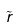Convert formula to latex. <formula><loc_0><loc_0><loc_500><loc_500>\tilde { r }</formula> 